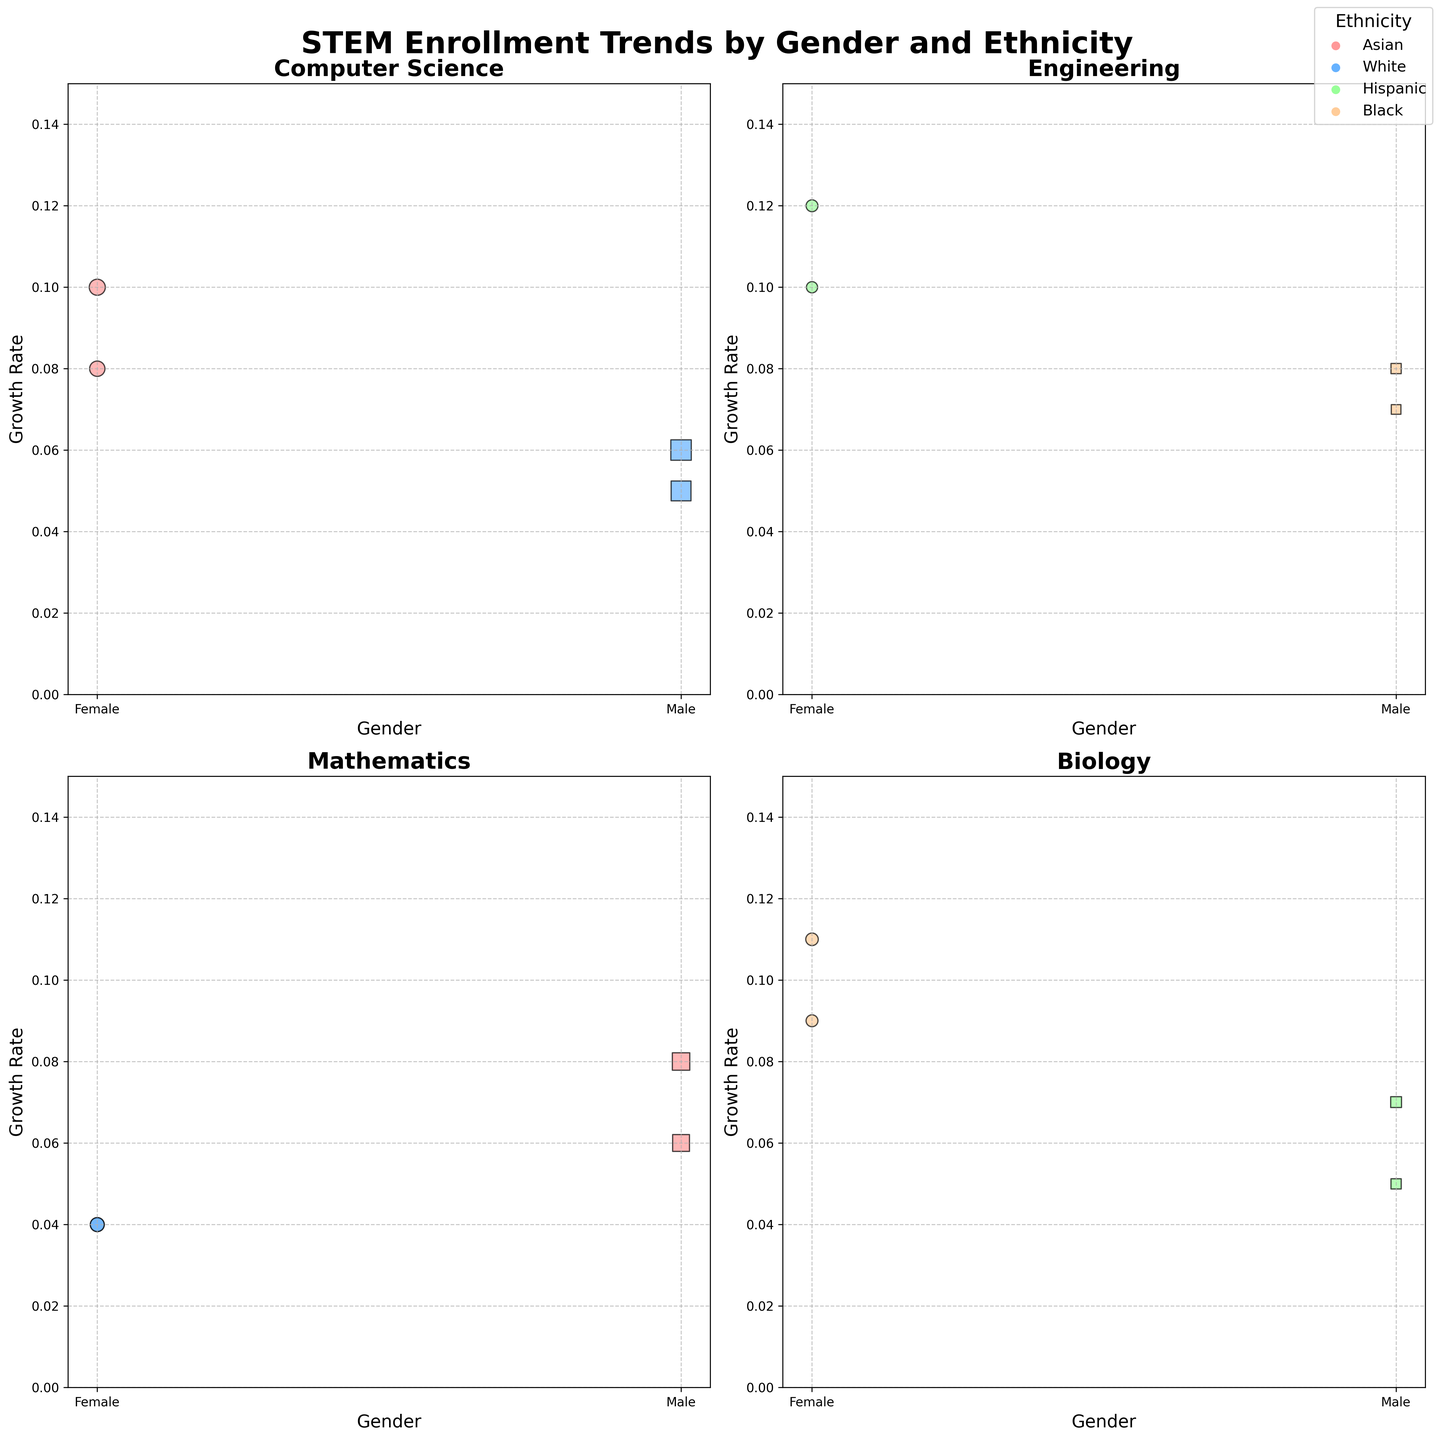What is the title of the figure? The title of the figure is displayed prominently at the top. It reads "STEM Enrollment Trends by Gender and Ethnicity".
Answer: STEM Enrollment Trends by Gender and Ethnicity Which axes represent "Gender" and "Growth Rate"? By looking at the structure of each subplot, the x-axis represents "Gender" and the y-axis represents "Growth Rate".
Answer: x-axis: Gender, y-axis: Growth Rate How many subplots are present in the figure? The figure is divided into four subplots, each representing different STEM fields: Computer Science, Engineering, Mathematics, and Biology.
Answer: 4 What color represents "Asian" ethnicity? The legend indicates that different colors represent different ethnicities; the color associated with "Asian" is red or a similar shade.
Answer: Light Red Which field shows the highest enrollment for females in 2020? To determine this, look at the sizes of the bubbles representing females across all fields for 2020. The largest bubble for females in 2020 is in "Computer Science" where "Asian" females show an enrollment of 15,000.
Answer: Computer Science Between 2020 and 2021, in which year did the "Black" females in "Biology" show a higher growth rate? Observe the growth rates for the "Black" females in "Biology" for both years. In 2020, the growth rate is 0.09, while in 2021, it is 0.11. The higher growth rate is in 2021.
Answer: 2021 Which gender shows a higher growth rate in "Mathematics" in 2021? Compare the growth rates for males and females in "Mathematics" in 2021. Males have a growth rate of 0.08, while females have a growth rate of 0.04. Males have a higher growth rate.
Answer: Male What is the difference in growth rate for "Hispanic" females in "Engineering" from 2020 to 2021? For "Hispanic" females in "Engineering," the growth rate in 2020 is 0.10, and in 2021 is 0.12. The difference is 0.12 - 0.10 = 0.02
Answer: 0.02 In "Computer Science," which ethnicity for males showed a higher enrollment in 2020? Examining the 2020 subplot for "Computer Science", the male enrollment bubbles show that "White" males had an enrollment of 25,000, while "Asian" males are not shown. Thus "White" males had higher enrollment.
Answer: White Which subplot shows the lowest overall growth rate across genders and ethnicities? By evaluating the y-axes across all subplots, it is evidenced that "Mathematics" has the lowest growth rates, as the highest value is around 0.08.
Answer: Mathematics 